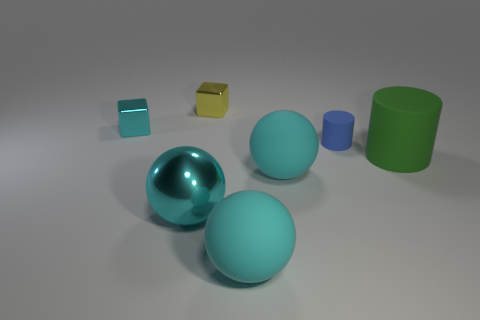Subtract all rubber balls. How many balls are left? 1 Add 2 blue rubber cylinders. How many objects exist? 9 Subtract all blue cylinders. How many cylinders are left? 1 Subtract all balls. How many objects are left? 4 Subtract all yellow cubes. How many blue cylinders are left? 1 Subtract 0 cyan cylinders. How many objects are left? 7 Subtract 2 spheres. How many spheres are left? 1 Subtract all blue balls. Subtract all purple blocks. How many balls are left? 3 Subtract all tiny cyan shiny objects. Subtract all big shiny objects. How many objects are left? 5 Add 6 cyan metallic spheres. How many cyan metallic spheres are left? 7 